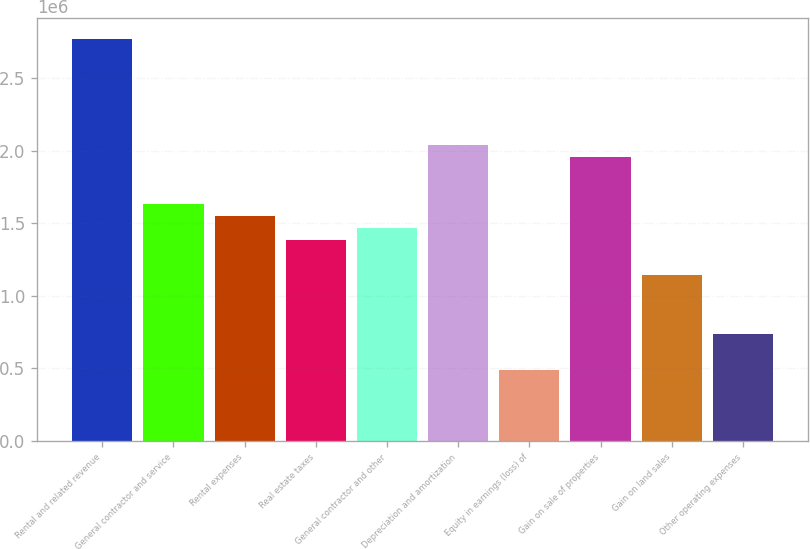Convert chart to OTSL. <chart><loc_0><loc_0><loc_500><loc_500><bar_chart><fcel>Rental and related revenue<fcel>General contractor and service<fcel>Rental expenses<fcel>Real estate taxes<fcel>General contractor and other<fcel>Depreciation and amortization<fcel>Equity in earnings (loss) of<fcel>Gain on sale of properties<fcel>Gain on land sales<fcel>Other operating expenses<nl><fcel>2.77462e+06<fcel>1.63213e+06<fcel>1.55052e+06<fcel>1.38731e+06<fcel>1.46892e+06<fcel>2.04016e+06<fcel>489639<fcel>1.95856e+06<fcel>1.14249e+06<fcel>734459<nl></chart> 